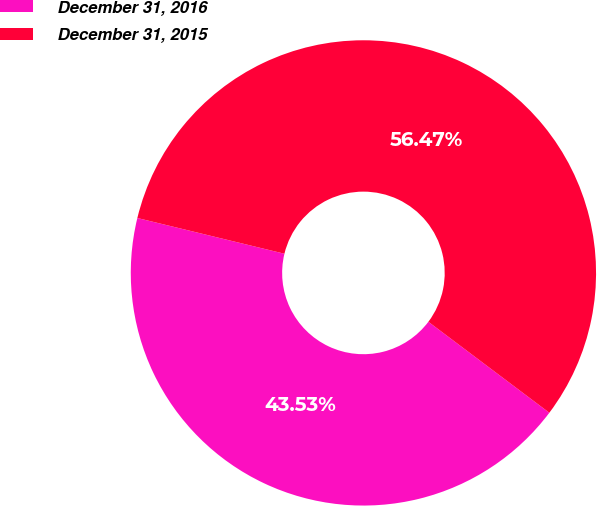Convert chart. <chart><loc_0><loc_0><loc_500><loc_500><pie_chart><fcel>December 31, 2016<fcel>December 31, 2015<nl><fcel>43.53%<fcel>56.47%<nl></chart> 